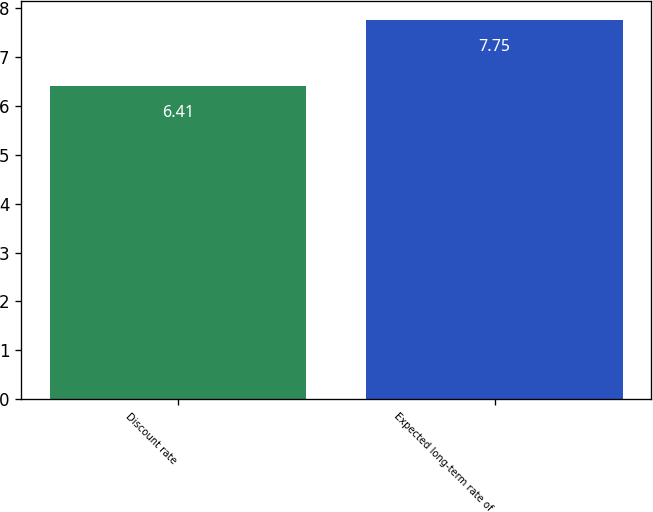Convert chart. <chart><loc_0><loc_0><loc_500><loc_500><bar_chart><fcel>Discount rate<fcel>Expected long-term rate of<nl><fcel>6.41<fcel>7.75<nl></chart> 